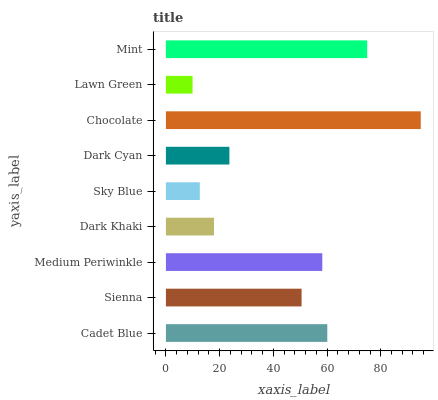Is Lawn Green the minimum?
Answer yes or no. Yes. Is Chocolate the maximum?
Answer yes or no. Yes. Is Sienna the minimum?
Answer yes or no. No. Is Sienna the maximum?
Answer yes or no. No. Is Cadet Blue greater than Sienna?
Answer yes or no. Yes. Is Sienna less than Cadet Blue?
Answer yes or no. Yes. Is Sienna greater than Cadet Blue?
Answer yes or no. No. Is Cadet Blue less than Sienna?
Answer yes or no. No. Is Sienna the high median?
Answer yes or no. Yes. Is Sienna the low median?
Answer yes or no. Yes. Is Dark Khaki the high median?
Answer yes or no. No. Is Dark Cyan the low median?
Answer yes or no. No. 